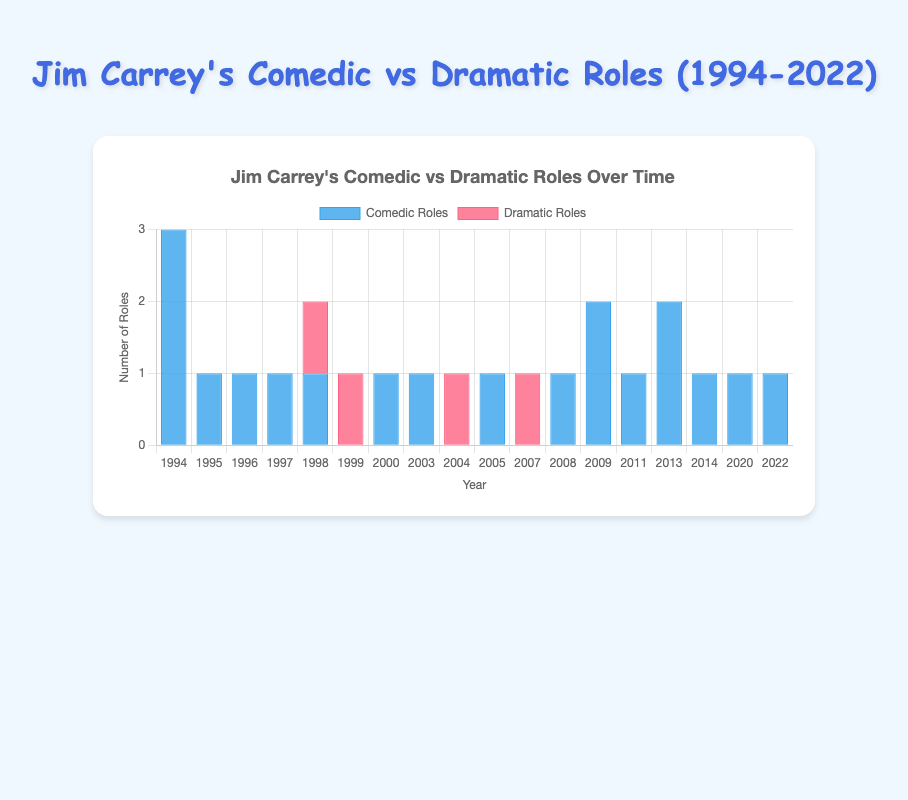**Comparison Questions**
1. Which year had the most comedic roles? By observing the bars representing comedic roles, 1994 stands out with the tallest bar indicating 3 comedic roles.
Answer: 1994 2. In which year did Jim Carrey have an equal number of comedic and dramatic roles? The bars show equal height for comedic and dramatic roles, representing 1 role each in 1998.
Answer: 1998 3. How many years did Jim Carrey have no dramatic roles? By counting the bars for dramatic roles that are not present (height of 0), there are 13 years with no dramatic roles.
Answer: 13 years **Compositional Questions**
4. What is the total number of comedic roles from 2010 to 2022? From 2010 onwards, the bars for comedic roles in 2011, 2013, 2014, 2020, and 2022 are 1, 2, 1, 1, and 1 respectively. Summing these values gives 6.
Answer: 6 5. What is the difference between the total number of comedic and dramatic roles throughout Jim Carrey's career? Sum all comedic roles (3+1+1+1+1+0+1+1+0+1+0+1+2+1+2+1+1+1) = 20. Sum all dramatic roles (0+0+0+0+1+1+0+0+1+0+1+0+0+0+0+0+0+0) = 4. The difference is 20-4 = 16.
Answer: 16 **Visual Questions**
6. Which color represents dramatic roles? By looking at the color of the bars that represent dramatic roles, they are red.
Answer: Red 7. During which years are there no bars at all for dramatic roles? The visual indicates no red bars in 1994, 1995, 1996, 1997, 2000, 2003, 2005, 2008, 2009, 2011, 2013, 2014, 2020, and 2022.
Answer: Multiple years (any of these years) 8. What was the height of the tallest bar in the chart? The tallest bar, representing comedic roles in 1994, reaches up to 3.
Answer: 3 